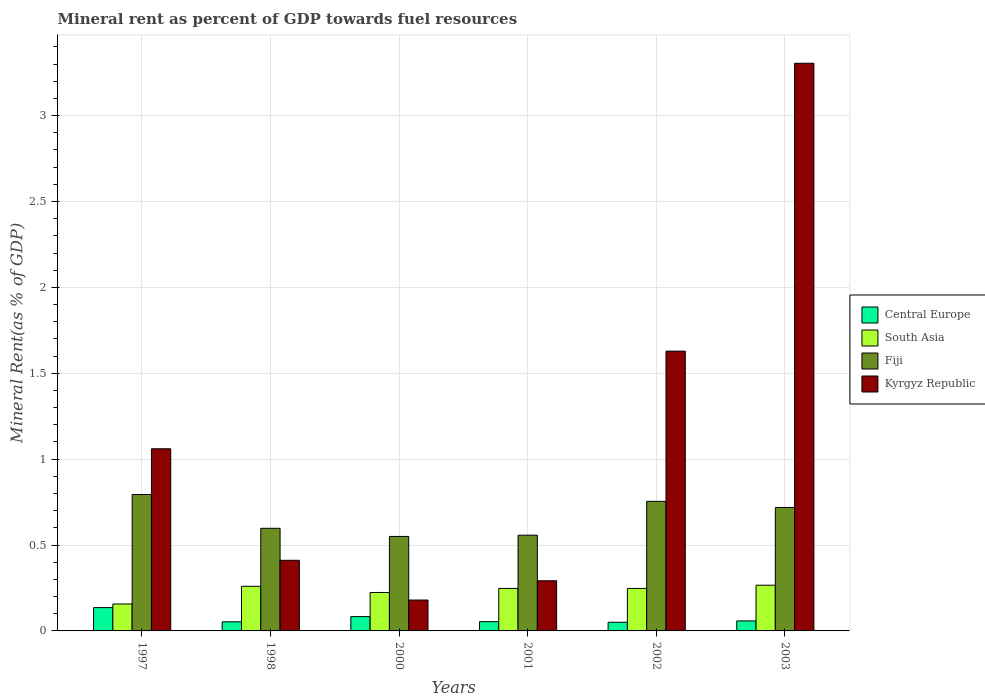Are the number of bars per tick equal to the number of legend labels?
Your answer should be very brief. Yes. In how many cases, is the number of bars for a given year not equal to the number of legend labels?
Offer a terse response. 0. What is the mineral rent in Fiji in 1997?
Give a very brief answer. 0.79. Across all years, what is the maximum mineral rent in Kyrgyz Republic?
Offer a terse response. 3.3. Across all years, what is the minimum mineral rent in Fiji?
Give a very brief answer. 0.55. What is the total mineral rent in Kyrgyz Republic in the graph?
Your answer should be very brief. 6.88. What is the difference between the mineral rent in Central Europe in 1998 and that in 2001?
Give a very brief answer. -0. What is the difference between the mineral rent in Fiji in 2000 and the mineral rent in Central Europe in 1997?
Your answer should be very brief. 0.41. What is the average mineral rent in Central Europe per year?
Make the answer very short. 0.07. In the year 1997, what is the difference between the mineral rent in Fiji and mineral rent in Kyrgyz Republic?
Make the answer very short. -0.27. What is the ratio of the mineral rent in Fiji in 1997 to that in 2002?
Your response must be concise. 1.05. Is the mineral rent in Central Europe in 2000 less than that in 2002?
Your answer should be compact. No. Is the difference between the mineral rent in Fiji in 1998 and 2000 greater than the difference between the mineral rent in Kyrgyz Republic in 1998 and 2000?
Offer a terse response. No. What is the difference between the highest and the second highest mineral rent in South Asia?
Provide a succinct answer. 0.01. What is the difference between the highest and the lowest mineral rent in Kyrgyz Republic?
Ensure brevity in your answer.  3.12. Is the sum of the mineral rent in South Asia in 1997 and 1998 greater than the maximum mineral rent in Fiji across all years?
Your response must be concise. No. What does the 3rd bar from the left in 1997 represents?
Provide a succinct answer. Fiji. Is it the case that in every year, the sum of the mineral rent in Fiji and mineral rent in Kyrgyz Republic is greater than the mineral rent in Central Europe?
Give a very brief answer. Yes. How many bars are there?
Your response must be concise. 24. What is the difference between two consecutive major ticks on the Y-axis?
Offer a very short reply. 0.5. Does the graph contain grids?
Your answer should be compact. Yes. Where does the legend appear in the graph?
Ensure brevity in your answer.  Center right. What is the title of the graph?
Ensure brevity in your answer.  Mineral rent as percent of GDP towards fuel resources. What is the label or title of the X-axis?
Your response must be concise. Years. What is the label or title of the Y-axis?
Ensure brevity in your answer.  Mineral Rent(as % of GDP). What is the Mineral Rent(as % of GDP) of Central Europe in 1997?
Your response must be concise. 0.14. What is the Mineral Rent(as % of GDP) in South Asia in 1997?
Make the answer very short. 0.16. What is the Mineral Rent(as % of GDP) of Fiji in 1997?
Your response must be concise. 0.79. What is the Mineral Rent(as % of GDP) in Kyrgyz Republic in 1997?
Ensure brevity in your answer.  1.06. What is the Mineral Rent(as % of GDP) of Central Europe in 1998?
Keep it short and to the point. 0.05. What is the Mineral Rent(as % of GDP) in South Asia in 1998?
Make the answer very short. 0.26. What is the Mineral Rent(as % of GDP) in Fiji in 1998?
Make the answer very short. 0.6. What is the Mineral Rent(as % of GDP) of Kyrgyz Republic in 1998?
Offer a terse response. 0.41. What is the Mineral Rent(as % of GDP) of Central Europe in 2000?
Keep it short and to the point. 0.08. What is the Mineral Rent(as % of GDP) of South Asia in 2000?
Keep it short and to the point. 0.22. What is the Mineral Rent(as % of GDP) in Fiji in 2000?
Your answer should be compact. 0.55. What is the Mineral Rent(as % of GDP) in Kyrgyz Republic in 2000?
Keep it short and to the point. 0.18. What is the Mineral Rent(as % of GDP) in Central Europe in 2001?
Your response must be concise. 0.05. What is the Mineral Rent(as % of GDP) of South Asia in 2001?
Provide a short and direct response. 0.25. What is the Mineral Rent(as % of GDP) of Fiji in 2001?
Your response must be concise. 0.56. What is the Mineral Rent(as % of GDP) of Kyrgyz Republic in 2001?
Your answer should be very brief. 0.29. What is the Mineral Rent(as % of GDP) of Central Europe in 2002?
Your answer should be very brief. 0.05. What is the Mineral Rent(as % of GDP) of South Asia in 2002?
Ensure brevity in your answer.  0.25. What is the Mineral Rent(as % of GDP) of Fiji in 2002?
Keep it short and to the point. 0.75. What is the Mineral Rent(as % of GDP) of Kyrgyz Republic in 2002?
Provide a short and direct response. 1.63. What is the Mineral Rent(as % of GDP) of Central Europe in 2003?
Provide a succinct answer. 0.06. What is the Mineral Rent(as % of GDP) in South Asia in 2003?
Provide a succinct answer. 0.27. What is the Mineral Rent(as % of GDP) in Fiji in 2003?
Ensure brevity in your answer.  0.72. What is the Mineral Rent(as % of GDP) of Kyrgyz Republic in 2003?
Your response must be concise. 3.3. Across all years, what is the maximum Mineral Rent(as % of GDP) in Central Europe?
Your answer should be compact. 0.14. Across all years, what is the maximum Mineral Rent(as % of GDP) in South Asia?
Offer a very short reply. 0.27. Across all years, what is the maximum Mineral Rent(as % of GDP) in Fiji?
Offer a terse response. 0.79. Across all years, what is the maximum Mineral Rent(as % of GDP) of Kyrgyz Republic?
Give a very brief answer. 3.3. Across all years, what is the minimum Mineral Rent(as % of GDP) in Central Europe?
Keep it short and to the point. 0.05. Across all years, what is the minimum Mineral Rent(as % of GDP) in South Asia?
Ensure brevity in your answer.  0.16. Across all years, what is the minimum Mineral Rent(as % of GDP) in Fiji?
Your answer should be very brief. 0.55. Across all years, what is the minimum Mineral Rent(as % of GDP) in Kyrgyz Republic?
Offer a very short reply. 0.18. What is the total Mineral Rent(as % of GDP) in Central Europe in the graph?
Your response must be concise. 0.43. What is the total Mineral Rent(as % of GDP) of South Asia in the graph?
Your response must be concise. 1.4. What is the total Mineral Rent(as % of GDP) in Fiji in the graph?
Provide a succinct answer. 3.97. What is the total Mineral Rent(as % of GDP) of Kyrgyz Republic in the graph?
Make the answer very short. 6.88. What is the difference between the Mineral Rent(as % of GDP) of Central Europe in 1997 and that in 1998?
Provide a succinct answer. 0.08. What is the difference between the Mineral Rent(as % of GDP) of South Asia in 1997 and that in 1998?
Keep it short and to the point. -0.1. What is the difference between the Mineral Rent(as % of GDP) in Fiji in 1997 and that in 1998?
Your answer should be very brief. 0.2. What is the difference between the Mineral Rent(as % of GDP) of Kyrgyz Republic in 1997 and that in 1998?
Make the answer very short. 0.65. What is the difference between the Mineral Rent(as % of GDP) in Central Europe in 1997 and that in 2000?
Your response must be concise. 0.05. What is the difference between the Mineral Rent(as % of GDP) in South Asia in 1997 and that in 2000?
Make the answer very short. -0.07. What is the difference between the Mineral Rent(as % of GDP) of Fiji in 1997 and that in 2000?
Your response must be concise. 0.24. What is the difference between the Mineral Rent(as % of GDP) of Kyrgyz Republic in 1997 and that in 2000?
Offer a very short reply. 0.88. What is the difference between the Mineral Rent(as % of GDP) in Central Europe in 1997 and that in 2001?
Offer a terse response. 0.08. What is the difference between the Mineral Rent(as % of GDP) in South Asia in 1997 and that in 2001?
Offer a very short reply. -0.09. What is the difference between the Mineral Rent(as % of GDP) of Fiji in 1997 and that in 2001?
Provide a succinct answer. 0.24. What is the difference between the Mineral Rent(as % of GDP) in Kyrgyz Republic in 1997 and that in 2001?
Offer a terse response. 0.77. What is the difference between the Mineral Rent(as % of GDP) in Central Europe in 1997 and that in 2002?
Keep it short and to the point. 0.09. What is the difference between the Mineral Rent(as % of GDP) in South Asia in 1997 and that in 2002?
Your answer should be very brief. -0.09. What is the difference between the Mineral Rent(as % of GDP) of Fiji in 1997 and that in 2002?
Keep it short and to the point. 0.04. What is the difference between the Mineral Rent(as % of GDP) in Kyrgyz Republic in 1997 and that in 2002?
Ensure brevity in your answer.  -0.57. What is the difference between the Mineral Rent(as % of GDP) in Central Europe in 1997 and that in 2003?
Provide a succinct answer. 0.08. What is the difference between the Mineral Rent(as % of GDP) in South Asia in 1997 and that in 2003?
Provide a short and direct response. -0.11. What is the difference between the Mineral Rent(as % of GDP) of Fiji in 1997 and that in 2003?
Offer a very short reply. 0.08. What is the difference between the Mineral Rent(as % of GDP) in Kyrgyz Republic in 1997 and that in 2003?
Provide a succinct answer. -2.24. What is the difference between the Mineral Rent(as % of GDP) in Central Europe in 1998 and that in 2000?
Provide a short and direct response. -0.03. What is the difference between the Mineral Rent(as % of GDP) in South Asia in 1998 and that in 2000?
Ensure brevity in your answer.  0.04. What is the difference between the Mineral Rent(as % of GDP) in Fiji in 1998 and that in 2000?
Ensure brevity in your answer.  0.05. What is the difference between the Mineral Rent(as % of GDP) in Kyrgyz Republic in 1998 and that in 2000?
Your response must be concise. 0.23. What is the difference between the Mineral Rent(as % of GDP) of Central Europe in 1998 and that in 2001?
Offer a terse response. -0. What is the difference between the Mineral Rent(as % of GDP) in South Asia in 1998 and that in 2001?
Your answer should be very brief. 0.01. What is the difference between the Mineral Rent(as % of GDP) in Fiji in 1998 and that in 2001?
Offer a terse response. 0.04. What is the difference between the Mineral Rent(as % of GDP) of Kyrgyz Republic in 1998 and that in 2001?
Offer a terse response. 0.12. What is the difference between the Mineral Rent(as % of GDP) of Central Europe in 1998 and that in 2002?
Make the answer very short. 0. What is the difference between the Mineral Rent(as % of GDP) in South Asia in 1998 and that in 2002?
Your answer should be very brief. 0.01. What is the difference between the Mineral Rent(as % of GDP) in Fiji in 1998 and that in 2002?
Your answer should be very brief. -0.16. What is the difference between the Mineral Rent(as % of GDP) of Kyrgyz Republic in 1998 and that in 2002?
Make the answer very short. -1.22. What is the difference between the Mineral Rent(as % of GDP) in Central Europe in 1998 and that in 2003?
Give a very brief answer. -0.01. What is the difference between the Mineral Rent(as % of GDP) of South Asia in 1998 and that in 2003?
Ensure brevity in your answer.  -0.01. What is the difference between the Mineral Rent(as % of GDP) of Fiji in 1998 and that in 2003?
Offer a terse response. -0.12. What is the difference between the Mineral Rent(as % of GDP) in Kyrgyz Republic in 1998 and that in 2003?
Your answer should be very brief. -2.89. What is the difference between the Mineral Rent(as % of GDP) in Central Europe in 2000 and that in 2001?
Make the answer very short. 0.03. What is the difference between the Mineral Rent(as % of GDP) of South Asia in 2000 and that in 2001?
Provide a short and direct response. -0.02. What is the difference between the Mineral Rent(as % of GDP) of Fiji in 2000 and that in 2001?
Give a very brief answer. -0.01. What is the difference between the Mineral Rent(as % of GDP) in Kyrgyz Republic in 2000 and that in 2001?
Your answer should be very brief. -0.11. What is the difference between the Mineral Rent(as % of GDP) of Central Europe in 2000 and that in 2002?
Ensure brevity in your answer.  0.03. What is the difference between the Mineral Rent(as % of GDP) in South Asia in 2000 and that in 2002?
Offer a terse response. -0.02. What is the difference between the Mineral Rent(as % of GDP) of Fiji in 2000 and that in 2002?
Provide a succinct answer. -0.2. What is the difference between the Mineral Rent(as % of GDP) of Kyrgyz Republic in 2000 and that in 2002?
Give a very brief answer. -1.45. What is the difference between the Mineral Rent(as % of GDP) in Central Europe in 2000 and that in 2003?
Your response must be concise. 0.03. What is the difference between the Mineral Rent(as % of GDP) in South Asia in 2000 and that in 2003?
Keep it short and to the point. -0.04. What is the difference between the Mineral Rent(as % of GDP) of Fiji in 2000 and that in 2003?
Make the answer very short. -0.17. What is the difference between the Mineral Rent(as % of GDP) in Kyrgyz Republic in 2000 and that in 2003?
Your response must be concise. -3.12. What is the difference between the Mineral Rent(as % of GDP) of Central Europe in 2001 and that in 2002?
Your answer should be very brief. 0. What is the difference between the Mineral Rent(as % of GDP) in Fiji in 2001 and that in 2002?
Give a very brief answer. -0.2. What is the difference between the Mineral Rent(as % of GDP) in Kyrgyz Republic in 2001 and that in 2002?
Ensure brevity in your answer.  -1.34. What is the difference between the Mineral Rent(as % of GDP) of Central Europe in 2001 and that in 2003?
Provide a succinct answer. -0. What is the difference between the Mineral Rent(as % of GDP) in South Asia in 2001 and that in 2003?
Make the answer very short. -0.02. What is the difference between the Mineral Rent(as % of GDP) in Fiji in 2001 and that in 2003?
Ensure brevity in your answer.  -0.16. What is the difference between the Mineral Rent(as % of GDP) in Kyrgyz Republic in 2001 and that in 2003?
Your response must be concise. -3.01. What is the difference between the Mineral Rent(as % of GDP) of Central Europe in 2002 and that in 2003?
Offer a very short reply. -0.01. What is the difference between the Mineral Rent(as % of GDP) in South Asia in 2002 and that in 2003?
Give a very brief answer. -0.02. What is the difference between the Mineral Rent(as % of GDP) in Fiji in 2002 and that in 2003?
Provide a short and direct response. 0.04. What is the difference between the Mineral Rent(as % of GDP) in Kyrgyz Republic in 2002 and that in 2003?
Your answer should be compact. -1.68. What is the difference between the Mineral Rent(as % of GDP) in Central Europe in 1997 and the Mineral Rent(as % of GDP) in South Asia in 1998?
Make the answer very short. -0.12. What is the difference between the Mineral Rent(as % of GDP) in Central Europe in 1997 and the Mineral Rent(as % of GDP) in Fiji in 1998?
Offer a very short reply. -0.46. What is the difference between the Mineral Rent(as % of GDP) in Central Europe in 1997 and the Mineral Rent(as % of GDP) in Kyrgyz Republic in 1998?
Your answer should be very brief. -0.28. What is the difference between the Mineral Rent(as % of GDP) in South Asia in 1997 and the Mineral Rent(as % of GDP) in Fiji in 1998?
Make the answer very short. -0.44. What is the difference between the Mineral Rent(as % of GDP) of South Asia in 1997 and the Mineral Rent(as % of GDP) of Kyrgyz Republic in 1998?
Offer a very short reply. -0.25. What is the difference between the Mineral Rent(as % of GDP) in Fiji in 1997 and the Mineral Rent(as % of GDP) in Kyrgyz Republic in 1998?
Make the answer very short. 0.38. What is the difference between the Mineral Rent(as % of GDP) in Central Europe in 1997 and the Mineral Rent(as % of GDP) in South Asia in 2000?
Offer a terse response. -0.09. What is the difference between the Mineral Rent(as % of GDP) in Central Europe in 1997 and the Mineral Rent(as % of GDP) in Fiji in 2000?
Offer a very short reply. -0.41. What is the difference between the Mineral Rent(as % of GDP) of Central Europe in 1997 and the Mineral Rent(as % of GDP) of Kyrgyz Republic in 2000?
Give a very brief answer. -0.04. What is the difference between the Mineral Rent(as % of GDP) in South Asia in 1997 and the Mineral Rent(as % of GDP) in Fiji in 2000?
Provide a short and direct response. -0.39. What is the difference between the Mineral Rent(as % of GDP) in South Asia in 1997 and the Mineral Rent(as % of GDP) in Kyrgyz Republic in 2000?
Offer a very short reply. -0.02. What is the difference between the Mineral Rent(as % of GDP) in Fiji in 1997 and the Mineral Rent(as % of GDP) in Kyrgyz Republic in 2000?
Give a very brief answer. 0.61. What is the difference between the Mineral Rent(as % of GDP) of Central Europe in 1997 and the Mineral Rent(as % of GDP) of South Asia in 2001?
Your answer should be very brief. -0.11. What is the difference between the Mineral Rent(as % of GDP) of Central Europe in 1997 and the Mineral Rent(as % of GDP) of Fiji in 2001?
Offer a terse response. -0.42. What is the difference between the Mineral Rent(as % of GDP) in Central Europe in 1997 and the Mineral Rent(as % of GDP) in Kyrgyz Republic in 2001?
Make the answer very short. -0.16. What is the difference between the Mineral Rent(as % of GDP) in South Asia in 1997 and the Mineral Rent(as % of GDP) in Fiji in 2001?
Your answer should be very brief. -0.4. What is the difference between the Mineral Rent(as % of GDP) of South Asia in 1997 and the Mineral Rent(as % of GDP) of Kyrgyz Republic in 2001?
Ensure brevity in your answer.  -0.14. What is the difference between the Mineral Rent(as % of GDP) of Fiji in 1997 and the Mineral Rent(as % of GDP) of Kyrgyz Republic in 2001?
Provide a succinct answer. 0.5. What is the difference between the Mineral Rent(as % of GDP) in Central Europe in 1997 and the Mineral Rent(as % of GDP) in South Asia in 2002?
Provide a short and direct response. -0.11. What is the difference between the Mineral Rent(as % of GDP) of Central Europe in 1997 and the Mineral Rent(as % of GDP) of Fiji in 2002?
Give a very brief answer. -0.62. What is the difference between the Mineral Rent(as % of GDP) of Central Europe in 1997 and the Mineral Rent(as % of GDP) of Kyrgyz Republic in 2002?
Your answer should be compact. -1.49. What is the difference between the Mineral Rent(as % of GDP) in South Asia in 1997 and the Mineral Rent(as % of GDP) in Fiji in 2002?
Offer a terse response. -0.6. What is the difference between the Mineral Rent(as % of GDP) of South Asia in 1997 and the Mineral Rent(as % of GDP) of Kyrgyz Republic in 2002?
Ensure brevity in your answer.  -1.47. What is the difference between the Mineral Rent(as % of GDP) in Fiji in 1997 and the Mineral Rent(as % of GDP) in Kyrgyz Republic in 2002?
Your response must be concise. -0.83. What is the difference between the Mineral Rent(as % of GDP) in Central Europe in 1997 and the Mineral Rent(as % of GDP) in South Asia in 2003?
Your answer should be very brief. -0.13. What is the difference between the Mineral Rent(as % of GDP) of Central Europe in 1997 and the Mineral Rent(as % of GDP) of Fiji in 2003?
Your answer should be compact. -0.58. What is the difference between the Mineral Rent(as % of GDP) in Central Europe in 1997 and the Mineral Rent(as % of GDP) in Kyrgyz Republic in 2003?
Make the answer very short. -3.17. What is the difference between the Mineral Rent(as % of GDP) in South Asia in 1997 and the Mineral Rent(as % of GDP) in Fiji in 2003?
Offer a terse response. -0.56. What is the difference between the Mineral Rent(as % of GDP) of South Asia in 1997 and the Mineral Rent(as % of GDP) of Kyrgyz Republic in 2003?
Your answer should be very brief. -3.15. What is the difference between the Mineral Rent(as % of GDP) in Fiji in 1997 and the Mineral Rent(as % of GDP) in Kyrgyz Republic in 2003?
Give a very brief answer. -2.51. What is the difference between the Mineral Rent(as % of GDP) in Central Europe in 1998 and the Mineral Rent(as % of GDP) in South Asia in 2000?
Your answer should be very brief. -0.17. What is the difference between the Mineral Rent(as % of GDP) of Central Europe in 1998 and the Mineral Rent(as % of GDP) of Fiji in 2000?
Keep it short and to the point. -0.5. What is the difference between the Mineral Rent(as % of GDP) in Central Europe in 1998 and the Mineral Rent(as % of GDP) in Kyrgyz Republic in 2000?
Your answer should be very brief. -0.13. What is the difference between the Mineral Rent(as % of GDP) in South Asia in 1998 and the Mineral Rent(as % of GDP) in Fiji in 2000?
Provide a short and direct response. -0.29. What is the difference between the Mineral Rent(as % of GDP) of South Asia in 1998 and the Mineral Rent(as % of GDP) of Kyrgyz Republic in 2000?
Keep it short and to the point. 0.08. What is the difference between the Mineral Rent(as % of GDP) in Fiji in 1998 and the Mineral Rent(as % of GDP) in Kyrgyz Republic in 2000?
Provide a succinct answer. 0.42. What is the difference between the Mineral Rent(as % of GDP) of Central Europe in 1998 and the Mineral Rent(as % of GDP) of South Asia in 2001?
Your answer should be very brief. -0.19. What is the difference between the Mineral Rent(as % of GDP) of Central Europe in 1998 and the Mineral Rent(as % of GDP) of Fiji in 2001?
Provide a short and direct response. -0.5. What is the difference between the Mineral Rent(as % of GDP) in Central Europe in 1998 and the Mineral Rent(as % of GDP) in Kyrgyz Republic in 2001?
Provide a succinct answer. -0.24. What is the difference between the Mineral Rent(as % of GDP) in South Asia in 1998 and the Mineral Rent(as % of GDP) in Fiji in 2001?
Ensure brevity in your answer.  -0.3. What is the difference between the Mineral Rent(as % of GDP) in South Asia in 1998 and the Mineral Rent(as % of GDP) in Kyrgyz Republic in 2001?
Provide a succinct answer. -0.03. What is the difference between the Mineral Rent(as % of GDP) in Fiji in 1998 and the Mineral Rent(as % of GDP) in Kyrgyz Republic in 2001?
Offer a very short reply. 0.31. What is the difference between the Mineral Rent(as % of GDP) of Central Europe in 1998 and the Mineral Rent(as % of GDP) of South Asia in 2002?
Make the answer very short. -0.19. What is the difference between the Mineral Rent(as % of GDP) of Central Europe in 1998 and the Mineral Rent(as % of GDP) of Fiji in 2002?
Keep it short and to the point. -0.7. What is the difference between the Mineral Rent(as % of GDP) of Central Europe in 1998 and the Mineral Rent(as % of GDP) of Kyrgyz Republic in 2002?
Provide a short and direct response. -1.58. What is the difference between the Mineral Rent(as % of GDP) in South Asia in 1998 and the Mineral Rent(as % of GDP) in Fiji in 2002?
Give a very brief answer. -0.49. What is the difference between the Mineral Rent(as % of GDP) of South Asia in 1998 and the Mineral Rent(as % of GDP) of Kyrgyz Republic in 2002?
Offer a terse response. -1.37. What is the difference between the Mineral Rent(as % of GDP) in Fiji in 1998 and the Mineral Rent(as % of GDP) in Kyrgyz Republic in 2002?
Provide a short and direct response. -1.03. What is the difference between the Mineral Rent(as % of GDP) in Central Europe in 1998 and the Mineral Rent(as % of GDP) in South Asia in 2003?
Your answer should be compact. -0.21. What is the difference between the Mineral Rent(as % of GDP) in Central Europe in 1998 and the Mineral Rent(as % of GDP) in Fiji in 2003?
Provide a succinct answer. -0.67. What is the difference between the Mineral Rent(as % of GDP) in Central Europe in 1998 and the Mineral Rent(as % of GDP) in Kyrgyz Republic in 2003?
Provide a short and direct response. -3.25. What is the difference between the Mineral Rent(as % of GDP) in South Asia in 1998 and the Mineral Rent(as % of GDP) in Fiji in 2003?
Your response must be concise. -0.46. What is the difference between the Mineral Rent(as % of GDP) in South Asia in 1998 and the Mineral Rent(as % of GDP) in Kyrgyz Republic in 2003?
Provide a short and direct response. -3.04. What is the difference between the Mineral Rent(as % of GDP) of Fiji in 1998 and the Mineral Rent(as % of GDP) of Kyrgyz Republic in 2003?
Keep it short and to the point. -2.71. What is the difference between the Mineral Rent(as % of GDP) of Central Europe in 2000 and the Mineral Rent(as % of GDP) of South Asia in 2001?
Your answer should be very brief. -0.16. What is the difference between the Mineral Rent(as % of GDP) in Central Europe in 2000 and the Mineral Rent(as % of GDP) in Fiji in 2001?
Make the answer very short. -0.47. What is the difference between the Mineral Rent(as % of GDP) in Central Europe in 2000 and the Mineral Rent(as % of GDP) in Kyrgyz Republic in 2001?
Your answer should be very brief. -0.21. What is the difference between the Mineral Rent(as % of GDP) of South Asia in 2000 and the Mineral Rent(as % of GDP) of Fiji in 2001?
Provide a short and direct response. -0.33. What is the difference between the Mineral Rent(as % of GDP) in South Asia in 2000 and the Mineral Rent(as % of GDP) in Kyrgyz Republic in 2001?
Your answer should be compact. -0.07. What is the difference between the Mineral Rent(as % of GDP) in Fiji in 2000 and the Mineral Rent(as % of GDP) in Kyrgyz Republic in 2001?
Offer a very short reply. 0.26. What is the difference between the Mineral Rent(as % of GDP) in Central Europe in 2000 and the Mineral Rent(as % of GDP) in South Asia in 2002?
Offer a terse response. -0.16. What is the difference between the Mineral Rent(as % of GDP) of Central Europe in 2000 and the Mineral Rent(as % of GDP) of Fiji in 2002?
Offer a very short reply. -0.67. What is the difference between the Mineral Rent(as % of GDP) of Central Europe in 2000 and the Mineral Rent(as % of GDP) of Kyrgyz Republic in 2002?
Provide a succinct answer. -1.55. What is the difference between the Mineral Rent(as % of GDP) in South Asia in 2000 and the Mineral Rent(as % of GDP) in Fiji in 2002?
Give a very brief answer. -0.53. What is the difference between the Mineral Rent(as % of GDP) in South Asia in 2000 and the Mineral Rent(as % of GDP) in Kyrgyz Republic in 2002?
Make the answer very short. -1.41. What is the difference between the Mineral Rent(as % of GDP) of Fiji in 2000 and the Mineral Rent(as % of GDP) of Kyrgyz Republic in 2002?
Keep it short and to the point. -1.08. What is the difference between the Mineral Rent(as % of GDP) of Central Europe in 2000 and the Mineral Rent(as % of GDP) of South Asia in 2003?
Your answer should be compact. -0.18. What is the difference between the Mineral Rent(as % of GDP) in Central Europe in 2000 and the Mineral Rent(as % of GDP) in Fiji in 2003?
Your response must be concise. -0.64. What is the difference between the Mineral Rent(as % of GDP) in Central Europe in 2000 and the Mineral Rent(as % of GDP) in Kyrgyz Republic in 2003?
Your response must be concise. -3.22. What is the difference between the Mineral Rent(as % of GDP) of South Asia in 2000 and the Mineral Rent(as % of GDP) of Fiji in 2003?
Give a very brief answer. -0.49. What is the difference between the Mineral Rent(as % of GDP) in South Asia in 2000 and the Mineral Rent(as % of GDP) in Kyrgyz Republic in 2003?
Keep it short and to the point. -3.08. What is the difference between the Mineral Rent(as % of GDP) in Fiji in 2000 and the Mineral Rent(as % of GDP) in Kyrgyz Republic in 2003?
Offer a terse response. -2.75. What is the difference between the Mineral Rent(as % of GDP) of Central Europe in 2001 and the Mineral Rent(as % of GDP) of South Asia in 2002?
Make the answer very short. -0.19. What is the difference between the Mineral Rent(as % of GDP) of Central Europe in 2001 and the Mineral Rent(as % of GDP) of Fiji in 2002?
Provide a short and direct response. -0.7. What is the difference between the Mineral Rent(as % of GDP) of Central Europe in 2001 and the Mineral Rent(as % of GDP) of Kyrgyz Republic in 2002?
Your answer should be compact. -1.57. What is the difference between the Mineral Rent(as % of GDP) in South Asia in 2001 and the Mineral Rent(as % of GDP) in Fiji in 2002?
Your answer should be compact. -0.51. What is the difference between the Mineral Rent(as % of GDP) in South Asia in 2001 and the Mineral Rent(as % of GDP) in Kyrgyz Republic in 2002?
Make the answer very short. -1.38. What is the difference between the Mineral Rent(as % of GDP) of Fiji in 2001 and the Mineral Rent(as % of GDP) of Kyrgyz Republic in 2002?
Offer a very short reply. -1.07. What is the difference between the Mineral Rent(as % of GDP) in Central Europe in 2001 and the Mineral Rent(as % of GDP) in South Asia in 2003?
Keep it short and to the point. -0.21. What is the difference between the Mineral Rent(as % of GDP) of Central Europe in 2001 and the Mineral Rent(as % of GDP) of Fiji in 2003?
Make the answer very short. -0.67. What is the difference between the Mineral Rent(as % of GDP) in Central Europe in 2001 and the Mineral Rent(as % of GDP) in Kyrgyz Republic in 2003?
Ensure brevity in your answer.  -3.25. What is the difference between the Mineral Rent(as % of GDP) of South Asia in 2001 and the Mineral Rent(as % of GDP) of Fiji in 2003?
Provide a short and direct response. -0.47. What is the difference between the Mineral Rent(as % of GDP) of South Asia in 2001 and the Mineral Rent(as % of GDP) of Kyrgyz Republic in 2003?
Your answer should be very brief. -3.06. What is the difference between the Mineral Rent(as % of GDP) in Fiji in 2001 and the Mineral Rent(as % of GDP) in Kyrgyz Republic in 2003?
Offer a terse response. -2.75. What is the difference between the Mineral Rent(as % of GDP) in Central Europe in 2002 and the Mineral Rent(as % of GDP) in South Asia in 2003?
Your response must be concise. -0.22. What is the difference between the Mineral Rent(as % of GDP) of Central Europe in 2002 and the Mineral Rent(as % of GDP) of Fiji in 2003?
Provide a short and direct response. -0.67. What is the difference between the Mineral Rent(as % of GDP) in Central Europe in 2002 and the Mineral Rent(as % of GDP) in Kyrgyz Republic in 2003?
Ensure brevity in your answer.  -3.25. What is the difference between the Mineral Rent(as % of GDP) of South Asia in 2002 and the Mineral Rent(as % of GDP) of Fiji in 2003?
Your answer should be compact. -0.47. What is the difference between the Mineral Rent(as % of GDP) in South Asia in 2002 and the Mineral Rent(as % of GDP) in Kyrgyz Republic in 2003?
Offer a terse response. -3.06. What is the difference between the Mineral Rent(as % of GDP) in Fiji in 2002 and the Mineral Rent(as % of GDP) in Kyrgyz Republic in 2003?
Provide a short and direct response. -2.55. What is the average Mineral Rent(as % of GDP) in Central Europe per year?
Give a very brief answer. 0.07. What is the average Mineral Rent(as % of GDP) of South Asia per year?
Give a very brief answer. 0.23. What is the average Mineral Rent(as % of GDP) in Fiji per year?
Provide a short and direct response. 0.66. What is the average Mineral Rent(as % of GDP) in Kyrgyz Republic per year?
Offer a terse response. 1.15. In the year 1997, what is the difference between the Mineral Rent(as % of GDP) of Central Europe and Mineral Rent(as % of GDP) of South Asia?
Your answer should be compact. -0.02. In the year 1997, what is the difference between the Mineral Rent(as % of GDP) in Central Europe and Mineral Rent(as % of GDP) in Fiji?
Make the answer very short. -0.66. In the year 1997, what is the difference between the Mineral Rent(as % of GDP) in Central Europe and Mineral Rent(as % of GDP) in Kyrgyz Republic?
Give a very brief answer. -0.92. In the year 1997, what is the difference between the Mineral Rent(as % of GDP) in South Asia and Mineral Rent(as % of GDP) in Fiji?
Offer a terse response. -0.64. In the year 1997, what is the difference between the Mineral Rent(as % of GDP) of South Asia and Mineral Rent(as % of GDP) of Kyrgyz Republic?
Your answer should be very brief. -0.9. In the year 1997, what is the difference between the Mineral Rent(as % of GDP) in Fiji and Mineral Rent(as % of GDP) in Kyrgyz Republic?
Offer a terse response. -0.27. In the year 1998, what is the difference between the Mineral Rent(as % of GDP) of Central Europe and Mineral Rent(as % of GDP) of South Asia?
Provide a succinct answer. -0.21. In the year 1998, what is the difference between the Mineral Rent(as % of GDP) in Central Europe and Mineral Rent(as % of GDP) in Fiji?
Make the answer very short. -0.54. In the year 1998, what is the difference between the Mineral Rent(as % of GDP) of Central Europe and Mineral Rent(as % of GDP) of Kyrgyz Republic?
Make the answer very short. -0.36. In the year 1998, what is the difference between the Mineral Rent(as % of GDP) of South Asia and Mineral Rent(as % of GDP) of Fiji?
Provide a short and direct response. -0.34. In the year 1998, what is the difference between the Mineral Rent(as % of GDP) of South Asia and Mineral Rent(as % of GDP) of Kyrgyz Republic?
Give a very brief answer. -0.15. In the year 1998, what is the difference between the Mineral Rent(as % of GDP) of Fiji and Mineral Rent(as % of GDP) of Kyrgyz Republic?
Make the answer very short. 0.19. In the year 2000, what is the difference between the Mineral Rent(as % of GDP) of Central Europe and Mineral Rent(as % of GDP) of South Asia?
Your answer should be compact. -0.14. In the year 2000, what is the difference between the Mineral Rent(as % of GDP) in Central Europe and Mineral Rent(as % of GDP) in Fiji?
Your answer should be very brief. -0.47. In the year 2000, what is the difference between the Mineral Rent(as % of GDP) in Central Europe and Mineral Rent(as % of GDP) in Kyrgyz Republic?
Keep it short and to the point. -0.1. In the year 2000, what is the difference between the Mineral Rent(as % of GDP) in South Asia and Mineral Rent(as % of GDP) in Fiji?
Your answer should be very brief. -0.33. In the year 2000, what is the difference between the Mineral Rent(as % of GDP) of South Asia and Mineral Rent(as % of GDP) of Kyrgyz Republic?
Provide a succinct answer. 0.04. In the year 2000, what is the difference between the Mineral Rent(as % of GDP) of Fiji and Mineral Rent(as % of GDP) of Kyrgyz Republic?
Provide a short and direct response. 0.37. In the year 2001, what is the difference between the Mineral Rent(as % of GDP) of Central Europe and Mineral Rent(as % of GDP) of South Asia?
Ensure brevity in your answer.  -0.19. In the year 2001, what is the difference between the Mineral Rent(as % of GDP) of Central Europe and Mineral Rent(as % of GDP) of Fiji?
Provide a succinct answer. -0.5. In the year 2001, what is the difference between the Mineral Rent(as % of GDP) of Central Europe and Mineral Rent(as % of GDP) of Kyrgyz Republic?
Offer a very short reply. -0.24. In the year 2001, what is the difference between the Mineral Rent(as % of GDP) of South Asia and Mineral Rent(as % of GDP) of Fiji?
Offer a terse response. -0.31. In the year 2001, what is the difference between the Mineral Rent(as % of GDP) of South Asia and Mineral Rent(as % of GDP) of Kyrgyz Republic?
Offer a very short reply. -0.04. In the year 2001, what is the difference between the Mineral Rent(as % of GDP) in Fiji and Mineral Rent(as % of GDP) in Kyrgyz Republic?
Offer a very short reply. 0.27. In the year 2002, what is the difference between the Mineral Rent(as % of GDP) of Central Europe and Mineral Rent(as % of GDP) of South Asia?
Your response must be concise. -0.2. In the year 2002, what is the difference between the Mineral Rent(as % of GDP) in Central Europe and Mineral Rent(as % of GDP) in Fiji?
Make the answer very short. -0.7. In the year 2002, what is the difference between the Mineral Rent(as % of GDP) of Central Europe and Mineral Rent(as % of GDP) of Kyrgyz Republic?
Make the answer very short. -1.58. In the year 2002, what is the difference between the Mineral Rent(as % of GDP) of South Asia and Mineral Rent(as % of GDP) of Fiji?
Your response must be concise. -0.51. In the year 2002, what is the difference between the Mineral Rent(as % of GDP) of South Asia and Mineral Rent(as % of GDP) of Kyrgyz Republic?
Make the answer very short. -1.38. In the year 2002, what is the difference between the Mineral Rent(as % of GDP) of Fiji and Mineral Rent(as % of GDP) of Kyrgyz Republic?
Ensure brevity in your answer.  -0.87. In the year 2003, what is the difference between the Mineral Rent(as % of GDP) of Central Europe and Mineral Rent(as % of GDP) of South Asia?
Offer a very short reply. -0.21. In the year 2003, what is the difference between the Mineral Rent(as % of GDP) of Central Europe and Mineral Rent(as % of GDP) of Fiji?
Provide a succinct answer. -0.66. In the year 2003, what is the difference between the Mineral Rent(as % of GDP) of Central Europe and Mineral Rent(as % of GDP) of Kyrgyz Republic?
Make the answer very short. -3.25. In the year 2003, what is the difference between the Mineral Rent(as % of GDP) in South Asia and Mineral Rent(as % of GDP) in Fiji?
Give a very brief answer. -0.45. In the year 2003, what is the difference between the Mineral Rent(as % of GDP) of South Asia and Mineral Rent(as % of GDP) of Kyrgyz Republic?
Keep it short and to the point. -3.04. In the year 2003, what is the difference between the Mineral Rent(as % of GDP) in Fiji and Mineral Rent(as % of GDP) in Kyrgyz Republic?
Provide a succinct answer. -2.59. What is the ratio of the Mineral Rent(as % of GDP) of Central Europe in 1997 to that in 1998?
Provide a short and direct response. 2.56. What is the ratio of the Mineral Rent(as % of GDP) in South Asia in 1997 to that in 1998?
Offer a very short reply. 0.6. What is the ratio of the Mineral Rent(as % of GDP) of Fiji in 1997 to that in 1998?
Provide a short and direct response. 1.33. What is the ratio of the Mineral Rent(as % of GDP) of Kyrgyz Republic in 1997 to that in 1998?
Your answer should be very brief. 2.58. What is the ratio of the Mineral Rent(as % of GDP) in Central Europe in 1997 to that in 2000?
Make the answer very short. 1.63. What is the ratio of the Mineral Rent(as % of GDP) in South Asia in 1997 to that in 2000?
Give a very brief answer. 0.7. What is the ratio of the Mineral Rent(as % of GDP) in Fiji in 1997 to that in 2000?
Your response must be concise. 1.44. What is the ratio of the Mineral Rent(as % of GDP) of Kyrgyz Republic in 1997 to that in 2000?
Give a very brief answer. 5.9. What is the ratio of the Mineral Rent(as % of GDP) of Central Europe in 1997 to that in 2001?
Offer a terse response. 2.52. What is the ratio of the Mineral Rent(as % of GDP) of South Asia in 1997 to that in 2001?
Provide a succinct answer. 0.63. What is the ratio of the Mineral Rent(as % of GDP) of Fiji in 1997 to that in 2001?
Your response must be concise. 1.42. What is the ratio of the Mineral Rent(as % of GDP) of Kyrgyz Republic in 1997 to that in 2001?
Offer a very short reply. 3.63. What is the ratio of the Mineral Rent(as % of GDP) in Central Europe in 1997 to that in 2002?
Ensure brevity in your answer.  2.69. What is the ratio of the Mineral Rent(as % of GDP) in South Asia in 1997 to that in 2002?
Make the answer very short. 0.63. What is the ratio of the Mineral Rent(as % of GDP) in Fiji in 1997 to that in 2002?
Keep it short and to the point. 1.05. What is the ratio of the Mineral Rent(as % of GDP) of Kyrgyz Republic in 1997 to that in 2002?
Keep it short and to the point. 0.65. What is the ratio of the Mineral Rent(as % of GDP) of Central Europe in 1997 to that in 2003?
Offer a very short reply. 2.34. What is the ratio of the Mineral Rent(as % of GDP) of South Asia in 1997 to that in 2003?
Your response must be concise. 0.59. What is the ratio of the Mineral Rent(as % of GDP) in Fiji in 1997 to that in 2003?
Ensure brevity in your answer.  1.1. What is the ratio of the Mineral Rent(as % of GDP) of Kyrgyz Republic in 1997 to that in 2003?
Offer a very short reply. 0.32. What is the ratio of the Mineral Rent(as % of GDP) in Central Europe in 1998 to that in 2000?
Offer a terse response. 0.64. What is the ratio of the Mineral Rent(as % of GDP) of South Asia in 1998 to that in 2000?
Keep it short and to the point. 1.16. What is the ratio of the Mineral Rent(as % of GDP) in Fiji in 1998 to that in 2000?
Your response must be concise. 1.09. What is the ratio of the Mineral Rent(as % of GDP) of Kyrgyz Republic in 1998 to that in 2000?
Ensure brevity in your answer.  2.29. What is the ratio of the Mineral Rent(as % of GDP) in Central Europe in 1998 to that in 2001?
Provide a short and direct response. 0.98. What is the ratio of the Mineral Rent(as % of GDP) of South Asia in 1998 to that in 2001?
Your answer should be very brief. 1.05. What is the ratio of the Mineral Rent(as % of GDP) of Fiji in 1998 to that in 2001?
Provide a short and direct response. 1.07. What is the ratio of the Mineral Rent(as % of GDP) in Kyrgyz Republic in 1998 to that in 2001?
Offer a very short reply. 1.41. What is the ratio of the Mineral Rent(as % of GDP) of Central Europe in 1998 to that in 2002?
Ensure brevity in your answer.  1.05. What is the ratio of the Mineral Rent(as % of GDP) of South Asia in 1998 to that in 2002?
Give a very brief answer. 1.05. What is the ratio of the Mineral Rent(as % of GDP) in Fiji in 1998 to that in 2002?
Give a very brief answer. 0.79. What is the ratio of the Mineral Rent(as % of GDP) of Kyrgyz Republic in 1998 to that in 2002?
Your response must be concise. 0.25. What is the ratio of the Mineral Rent(as % of GDP) of Central Europe in 1998 to that in 2003?
Ensure brevity in your answer.  0.91. What is the ratio of the Mineral Rent(as % of GDP) in South Asia in 1998 to that in 2003?
Give a very brief answer. 0.98. What is the ratio of the Mineral Rent(as % of GDP) of Fiji in 1998 to that in 2003?
Keep it short and to the point. 0.83. What is the ratio of the Mineral Rent(as % of GDP) in Kyrgyz Republic in 1998 to that in 2003?
Your response must be concise. 0.12. What is the ratio of the Mineral Rent(as % of GDP) of Central Europe in 2000 to that in 2001?
Keep it short and to the point. 1.55. What is the ratio of the Mineral Rent(as % of GDP) of South Asia in 2000 to that in 2001?
Provide a succinct answer. 0.9. What is the ratio of the Mineral Rent(as % of GDP) in Kyrgyz Republic in 2000 to that in 2001?
Your answer should be very brief. 0.62. What is the ratio of the Mineral Rent(as % of GDP) in Central Europe in 2000 to that in 2002?
Keep it short and to the point. 1.65. What is the ratio of the Mineral Rent(as % of GDP) of South Asia in 2000 to that in 2002?
Offer a terse response. 0.9. What is the ratio of the Mineral Rent(as % of GDP) in Fiji in 2000 to that in 2002?
Give a very brief answer. 0.73. What is the ratio of the Mineral Rent(as % of GDP) of Kyrgyz Republic in 2000 to that in 2002?
Make the answer very short. 0.11. What is the ratio of the Mineral Rent(as % of GDP) of Central Europe in 2000 to that in 2003?
Provide a short and direct response. 1.43. What is the ratio of the Mineral Rent(as % of GDP) in South Asia in 2000 to that in 2003?
Your response must be concise. 0.84. What is the ratio of the Mineral Rent(as % of GDP) in Fiji in 2000 to that in 2003?
Make the answer very short. 0.77. What is the ratio of the Mineral Rent(as % of GDP) in Kyrgyz Republic in 2000 to that in 2003?
Your answer should be very brief. 0.05. What is the ratio of the Mineral Rent(as % of GDP) in Central Europe in 2001 to that in 2002?
Your answer should be very brief. 1.06. What is the ratio of the Mineral Rent(as % of GDP) in South Asia in 2001 to that in 2002?
Keep it short and to the point. 1. What is the ratio of the Mineral Rent(as % of GDP) in Fiji in 2001 to that in 2002?
Your response must be concise. 0.74. What is the ratio of the Mineral Rent(as % of GDP) of Kyrgyz Republic in 2001 to that in 2002?
Your response must be concise. 0.18. What is the ratio of the Mineral Rent(as % of GDP) in Central Europe in 2001 to that in 2003?
Offer a very short reply. 0.93. What is the ratio of the Mineral Rent(as % of GDP) in South Asia in 2001 to that in 2003?
Your answer should be compact. 0.93. What is the ratio of the Mineral Rent(as % of GDP) of Fiji in 2001 to that in 2003?
Your answer should be very brief. 0.78. What is the ratio of the Mineral Rent(as % of GDP) in Kyrgyz Republic in 2001 to that in 2003?
Provide a succinct answer. 0.09. What is the ratio of the Mineral Rent(as % of GDP) in Central Europe in 2002 to that in 2003?
Your answer should be very brief. 0.87. What is the ratio of the Mineral Rent(as % of GDP) in South Asia in 2002 to that in 2003?
Ensure brevity in your answer.  0.93. What is the ratio of the Mineral Rent(as % of GDP) in Fiji in 2002 to that in 2003?
Make the answer very short. 1.05. What is the ratio of the Mineral Rent(as % of GDP) of Kyrgyz Republic in 2002 to that in 2003?
Provide a short and direct response. 0.49. What is the difference between the highest and the second highest Mineral Rent(as % of GDP) in Central Europe?
Offer a very short reply. 0.05. What is the difference between the highest and the second highest Mineral Rent(as % of GDP) in South Asia?
Provide a short and direct response. 0.01. What is the difference between the highest and the second highest Mineral Rent(as % of GDP) of Fiji?
Offer a terse response. 0.04. What is the difference between the highest and the second highest Mineral Rent(as % of GDP) in Kyrgyz Republic?
Provide a succinct answer. 1.68. What is the difference between the highest and the lowest Mineral Rent(as % of GDP) of Central Europe?
Provide a short and direct response. 0.09. What is the difference between the highest and the lowest Mineral Rent(as % of GDP) in South Asia?
Your answer should be compact. 0.11. What is the difference between the highest and the lowest Mineral Rent(as % of GDP) in Fiji?
Offer a terse response. 0.24. What is the difference between the highest and the lowest Mineral Rent(as % of GDP) of Kyrgyz Republic?
Your answer should be compact. 3.12. 